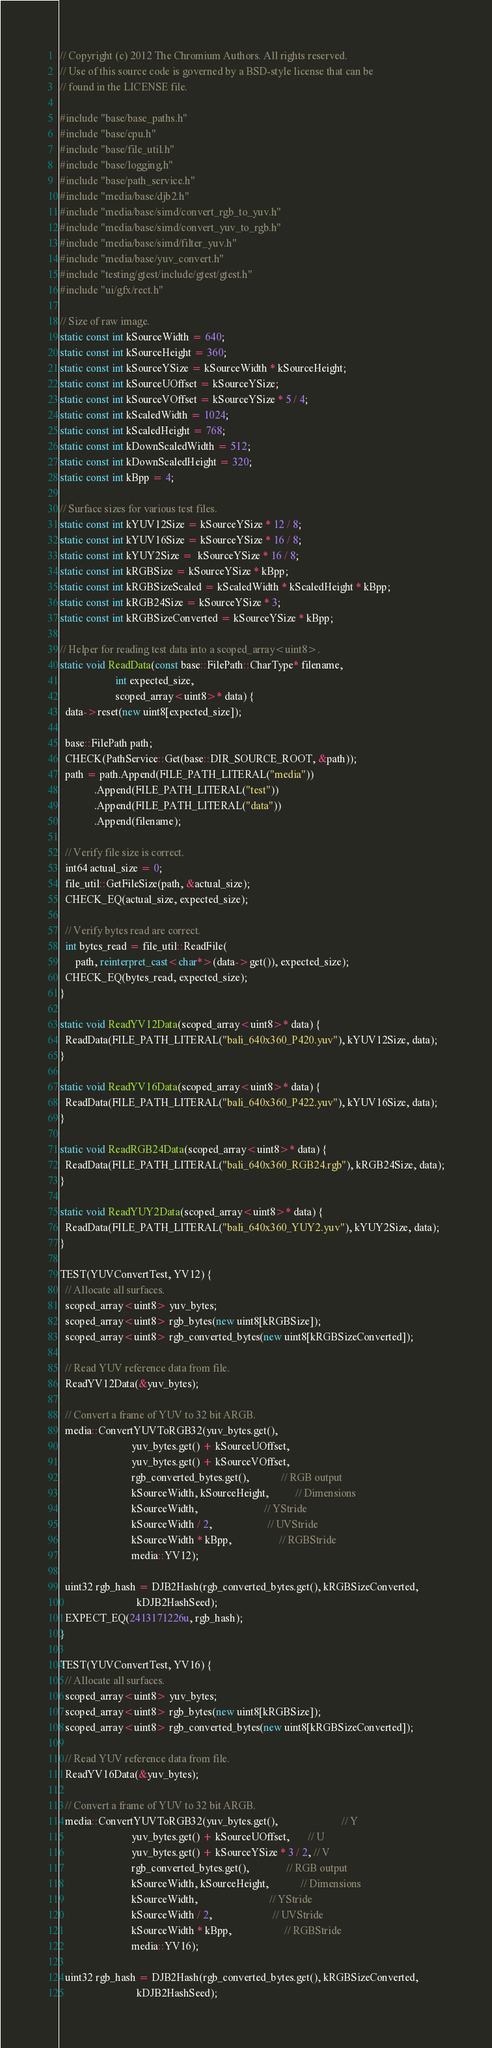Convert code to text. <code><loc_0><loc_0><loc_500><loc_500><_C++_>// Copyright (c) 2012 The Chromium Authors. All rights reserved.
// Use of this source code is governed by a BSD-style license that can be
// found in the LICENSE file.

#include "base/base_paths.h"
#include "base/cpu.h"
#include "base/file_util.h"
#include "base/logging.h"
#include "base/path_service.h"
#include "media/base/djb2.h"
#include "media/base/simd/convert_rgb_to_yuv.h"
#include "media/base/simd/convert_yuv_to_rgb.h"
#include "media/base/simd/filter_yuv.h"
#include "media/base/yuv_convert.h"
#include "testing/gtest/include/gtest/gtest.h"
#include "ui/gfx/rect.h"

// Size of raw image.
static const int kSourceWidth = 640;
static const int kSourceHeight = 360;
static const int kSourceYSize = kSourceWidth * kSourceHeight;
static const int kSourceUOffset = kSourceYSize;
static const int kSourceVOffset = kSourceYSize * 5 / 4;
static const int kScaledWidth = 1024;
static const int kScaledHeight = 768;
static const int kDownScaledWidth = 512;
static const int kDownScaledHeight = 320;
static const int kBpp = 4;

// Surface sizes for various test files.
static const int kYUV12Size = kSourceYSize * 12 / 8;
static const int kYUV16Size = kSourceYSize * 16 / 8;
static const int kYUY2Size =  kSourceYSize * 16 / 8;
static const int kRGBSize = kSourceYSize * kBpp;
static const int kRGBSizeScaled = kScaledWidth * kScaledHeight * kBpp;
static const int kRGB24Size = kSourceYSize * 3;
static const int kRGBSizeConverted = kSourceYSize * kBpp;

// Helper for reading test data into a scoped_array<uint8>.
static void ReadData(const base::FilePath::CharType* filename,
                     int expected_size,
                     scoped_array<uint8>* data) {
  data->reset(new uint8[expected_size]);

  base::FilePath path;
  CHECK(PathService::Get(base::DIR_SOURCE_ROOT, &path));
  path = path.Append(FILE_PATH_LITERAL("media"))
             .Append(FILE_PATH_LITERAL("test"))
             .Append(FILE_PATH_LITERAL("data"))
             .Append(filename);

  // Verify file size is correct.
  int64 actual_size = 0;
  file_util::GetFileSize(path, &actual_size);
  CHECK_EQ(actual_size, expected_size);

  // Verify bytes read are correct.
  int bytes_read = file_util::ReadFile(
      path, reinterpret_cast<char*>(data->get()), expected_size);
  CHECK_EQ(bytes_read, expected_size);
}

static void ReadYV12Data(scoped_array<uint8>* data) {
  ReadData(FILE_PATH_LITERAL("bali_640x360_P420.yuv"), kYUV12Size, data);
}

static void ReadYV16Data(scoped_array<uint8>* data) {
  ReadData(FILE_PATH_LITERAL("bali_640x360_P422.yuv"), kYUV16Size, data);
}

static void ReadRGB24Data(scoped_array<uint8>* data) {
  ReadData(FILE_PATH_LITERAL("bali_640x360_RGB24.rgb"), kRGB24Size, data);
}

static void ReadYUY2Data(scoped_array<uint8>* data) {
  ReadData(FILE_PATH_LITERAL("bali_640x360_YUY2.yuv"), kYUY2Size, data);
}

TEST(YUVConvertTest, YV12) {
  // Allocate all surfaces.
  scoped_array<uint8> yuv_bytes;
  scoped_array<uint8> rgb_bytes(new uint8[kRGBSize]);
  scoped_array<uint8> rgb_converted_bytes(new uint8[kRGBSizeConverted]);

  // Read YUV reference data from file.
  ReadYV12Data(&yuv_bytes);

  // Convert a frame of YUV to 32 bit ARGB.
  media::ConvertYUVToRGB32(yuv_bytes.get(),
                           yuv_bytes.get() + kSourceUOffset,
                           yuv_bytes.get() + kSourceVOffset,
                           rgb_converted_bytes.get(),            // RGB output
                           kSourceWidth, kSourceHeight,          // Dimensions
                           kSourceWidth,                         // YStride
                           kSourceWidth / 2,                     // UVStride
                           kSourceWidth * kBpp,                  // RGBStride
                           media::YV12);

  uint32 rgb_hash = DJB2Hash(rgb_converted_bytes.get(), kRGBSizeConverted,
                             kDJB2HashSeed);
  EXPECT_EQ(2413171226u, rgb_hash);
}

TEST(YUVConvertTest, YV16) {
  // Allocate all surfaces.
  scoped_array<uint8> yuv_bytes;
  scoped_array<uint8> rgb_bytes(new uint8[kRGBSize]);
  scoped_array<uint8> rgb_converted_bytes(new uint8[kRGBSizeConverted]);

  // Read YUV reference data from file.
  ReadYV16Data(&yuv_bytes);

  // Convert a frame of YUV to 32 bit ARGB.
  media::ConvertYUVToRGB32(yuv_bytes.get(),                        // Y
                           yuv_bytes.get() + kSourceUOffset,       // U
                           yuv_bytes.get() + kSourceYSize * 3 / 2, // V
                           rgb_converted_bytes.get(),              // RGB output
                           kSourceWidth, kSourceHeight,            // Dimensions
                           kSourceWidth,                           // YStride
                           kSourceWidth / 2,                       // UVStride
                           kSourceWidth * kBpp,                    // RGBStride
                           media::YV16);

  uint32 rgb_hash = DJB2Hash(rgb_converted_bytes.get(), kRGBSizeConverted,
                             kDJB2HashSeed);</code> 